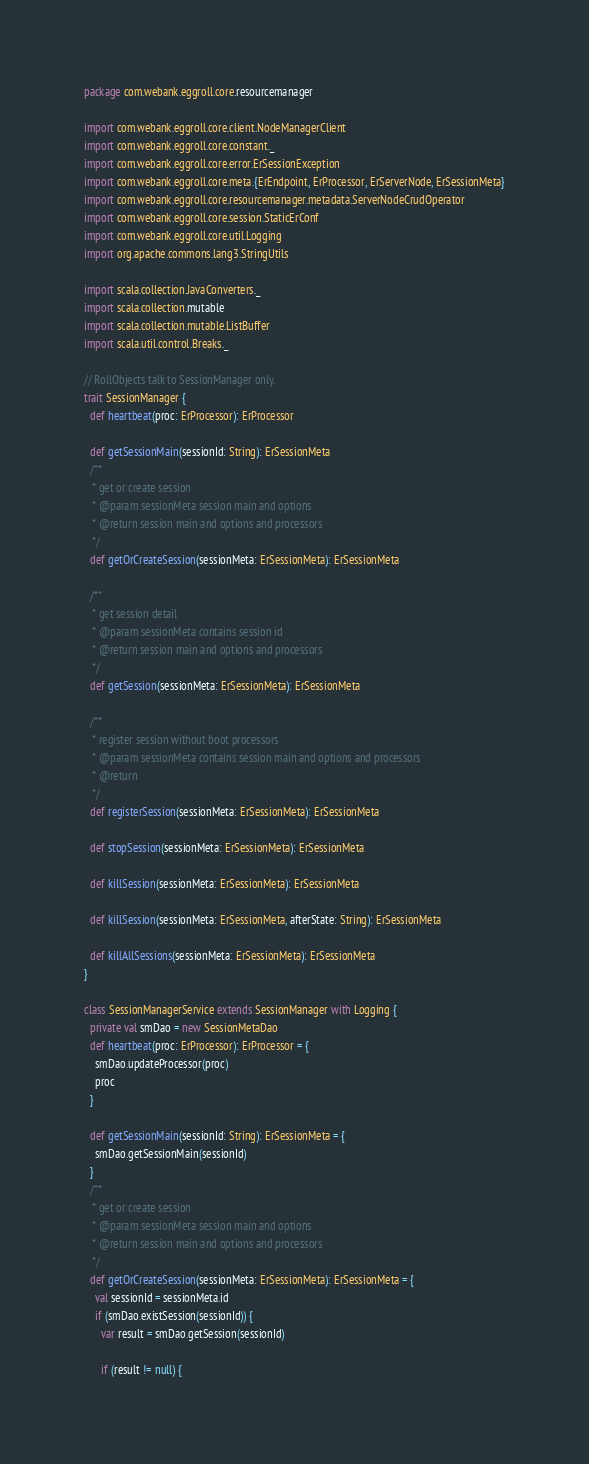<code> <loc_0><loc_0><loc_500><loc_500><_Scala_>package com.webank.eggroll.core.resourcemanager

import com.webank.eggroll.core.client.NodeManagerClient
import com.webank.eggroll.core.constant._
import com.webank.eggroll.core.error.ErSessionException
import com.webank.eggroll.core.meta.{ErEndpoint, ErProcessor, ErServerNode, ErSessionMeta}
import com.webank.eggroll.core.resourcemanager.metadata.ServerNodeCrudOperator
import com.webank.eggroll.core.session.StaticErConf
import com.webank.eggroll.core.util.Logging
import org.apache.commons.lang3.StringUtils

import scala.collection.JavaConverters._
import scala.collection.mutable
import scala.collection.mutable.ListBuffer
import scala.util.control.Breaks._

// RollObjects talk to SessionManager only.
trait SessionManager {
  def heartbeat(proc: ErProcessor): ErProcessor

  def getSessionMain(sessionId: String): ErSessionMeta
  /**
   * get or create session
   * @param sessionMeta session main and options
   * @return session main and options and processors
   */
  def getOrCreateSession(sessionMeta: ErSessionMeta): ErSessionMeta

  /**
   * get session detail
   * @param sessionMeta contains session id
   * @return session main and options and processors
   */
  def getSession(sessionMeta: ErSessionMeta): ErSessionMeta

  /**
   * register session without boot processors
   * @param sessionMeta contains session main and options and processors
   * @return
   */
  def registerSession(sessionMeta: ErSessionMeta): ErSessionMeta

  def stopSession(sessionMeta: ErSessionMeta): ErSessionMeta

  def killSession(sessionMeta: ErSessionMeta): ErSessionMeta

  def killSession(sessionMeta: ErSessionMeta, afterState: String): ErSessionMeta

  def killAllSessions(sessionMeta: ErSessionMeta): ErSessionMeta
}

class SessionManagerService extends SessionManager with Logging {
  private val smDao = new SessionMetaDao
  def heartbeat(proc: ErProcessor): ErProcessor = {
    smDao.updateProcessor(proc)
    proc
  }

  def getSessionMain(sessionId: String): ErSessionMeta = {
    smDao.getSessionMain(sessionId)
  }
  /**
   * get or create session
   * @param sessionMeta session main and options
   * @return session main and options and processors
   */
  def getOrCreateSession(sessionMeta: ErSessionMeta): ErSessionMeta = {
    val sessionId = sessionMeta.id
    if (smDao.existSession(sessionId)) {
      var result = smDao.getSession(sessionId)

      if (result != null) {</code> 